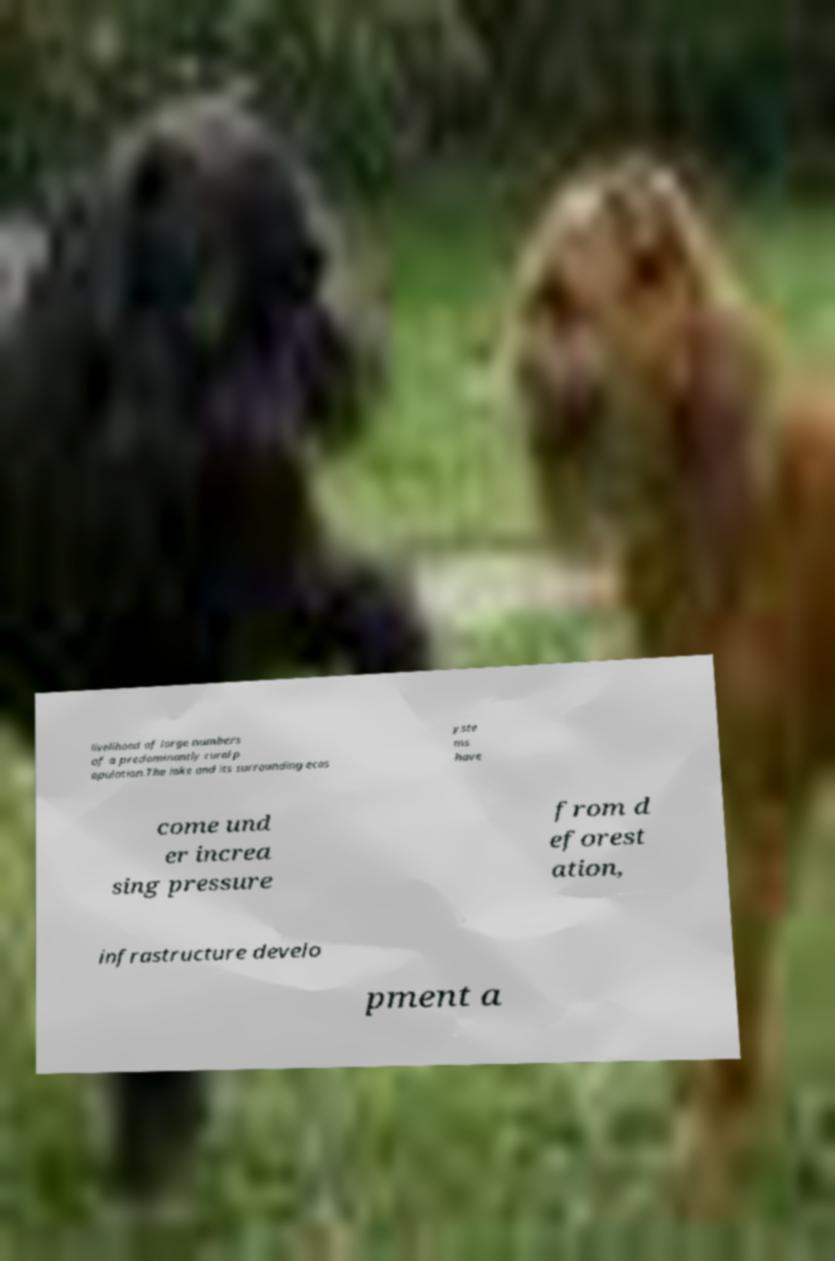There's text embedded in this image that I need extracted. Can you transcribe it verbatim? livelihood of large numbers of a predominantly rural p opulation.The lake and its surrounding ecos yste ms have come und er increa sing pressure from d eforest ation, infrastructure develo pment a 